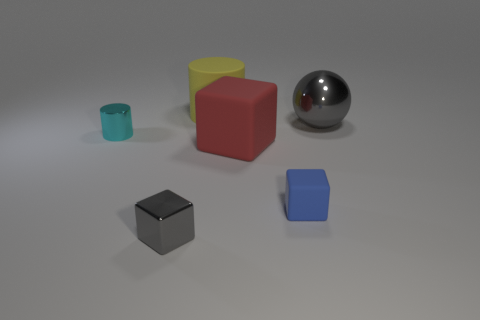What color is the large cube that is made of the same material as the small blue thing?
Ensure brevity in your answer.  Red. What number of small cyan cylinders are made of the same material as the yellow thing?
Provide a succinct answer. 0. Is the material of the large yellow thing the same as the large object in front of the ball?
Your response must be concise. Yes. How many things are metallic things left of the yellow matte object or large red rubber things?
Make the answer very short. 3. There is a gray metallic thing in front of the metal object that is to the right of the small blue thing on the left side of the large gray shiny sphere; how big is it?
Provide a short and direct response. Small. What is the material of the ball that is the same color as the tiny metallic cube?
Offer a very short reply. Metal. Are there any other things that are the same shape as the small blue object?
Your response must be concise. Yes. There is a cylinder in front of the big thing left of the red cube; what is its size?
Your answer should be very brief. Small. What number of big objects are either objects or blue matte blocks?
Your answer should be very brief. 3. Is the number of large blue matte cubes less than the number of yellow things?
Give a very brief answer. Yes. 